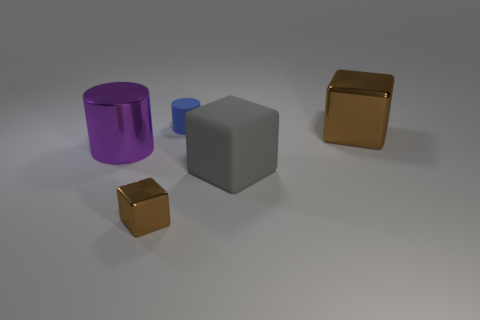Subtract all big blocks. How many blocks are left? 1 Add 4 big brown shiny things. How many objects exist? 9 Subtract all gray cubes. How many cubes are left? 2 Subtract all cubes. How many objects are left? 2 Subtract all blue blocks. Subtract all yellow balls. How many blocks are left? 3 Subtract all brown cylinders. How many gray blocks are left? 1 Subtract all blue rubber objects. Subtract all brown things. How many objects are left? 2 Add 5 small brown blocks. How many small brown blocks are left? 6 Add 4 tiny brown rubber cylinders. How many tiny brown rubber cylinders exist? 4 Subtract 0 green cubes. How many objects are left? 5 